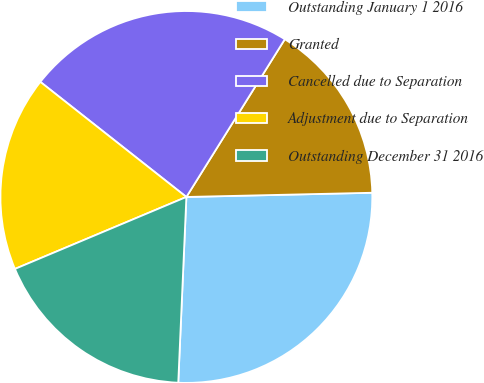Convert chart. <chart><loc_0><loc_0><loc_500><loc_500><pie_chart><fcel>Outstanding January 1 2016<fcel>Granted<fcel>Cancelled due to Separation<fcel>Adjustment due to Separation<fcel>Outstanding December 31 2016<nl><fcel>26.06%<fcel>15.76%<fcel>23.26%<fcel>16.95%<fcel>17.98%<nl></chart> 